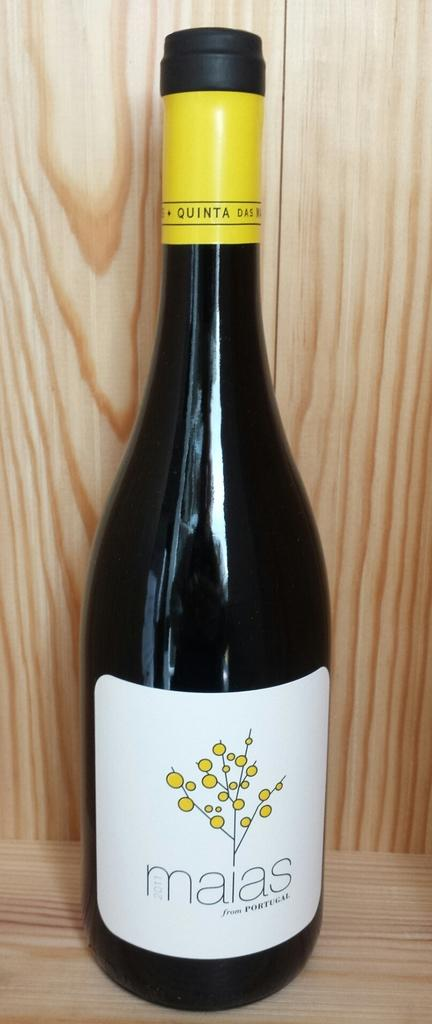Provide a one-sentence caption for the provided image. A bottle of maias wine from Portugal has a yellow band around the neck. 